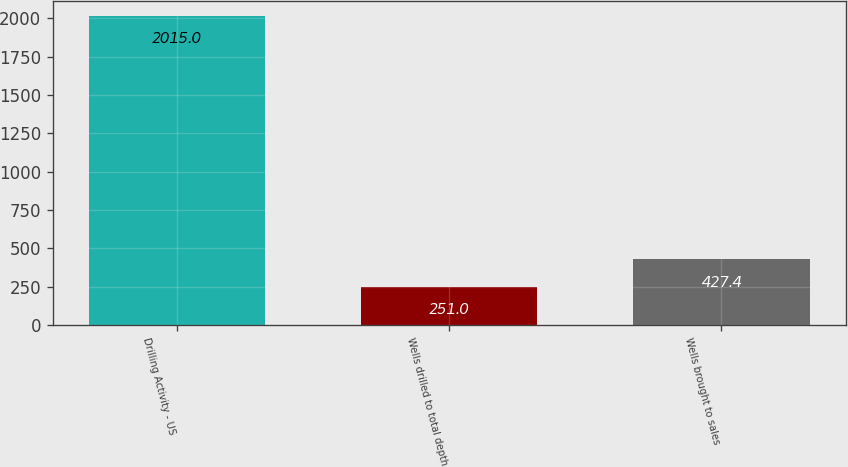<chart> <loc_0><loc_0><loc_500><loc_500><bar_chart><fcel>Drilling Activity - US<fcel>Wells drilled to total depth<fcel>Wells brought to sales<nl><fcel>2015<fcel>251<fcel>427.4<nl></chart> 